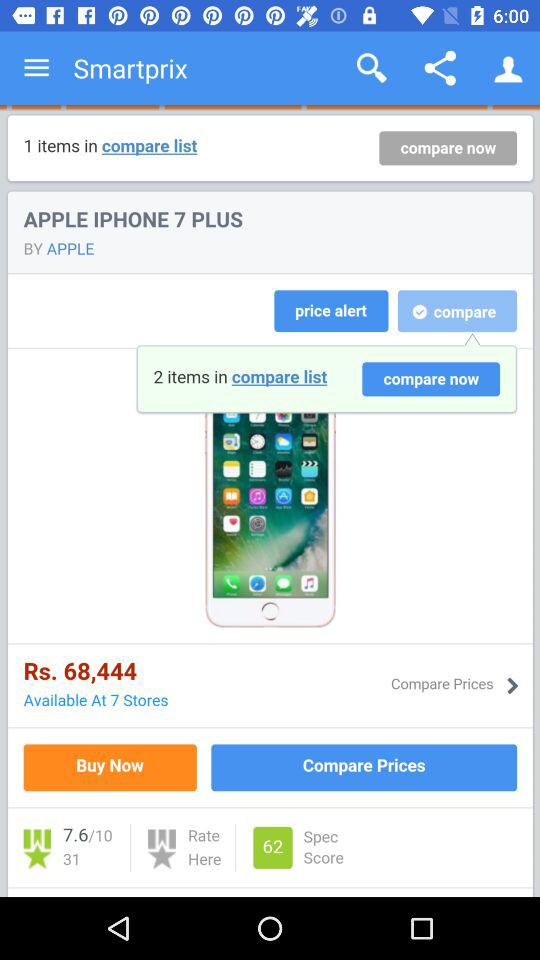In how many stores is the Apple iPhone 7 Plus available? The Apple iPhone 7 Plus is available in 7 stores. 